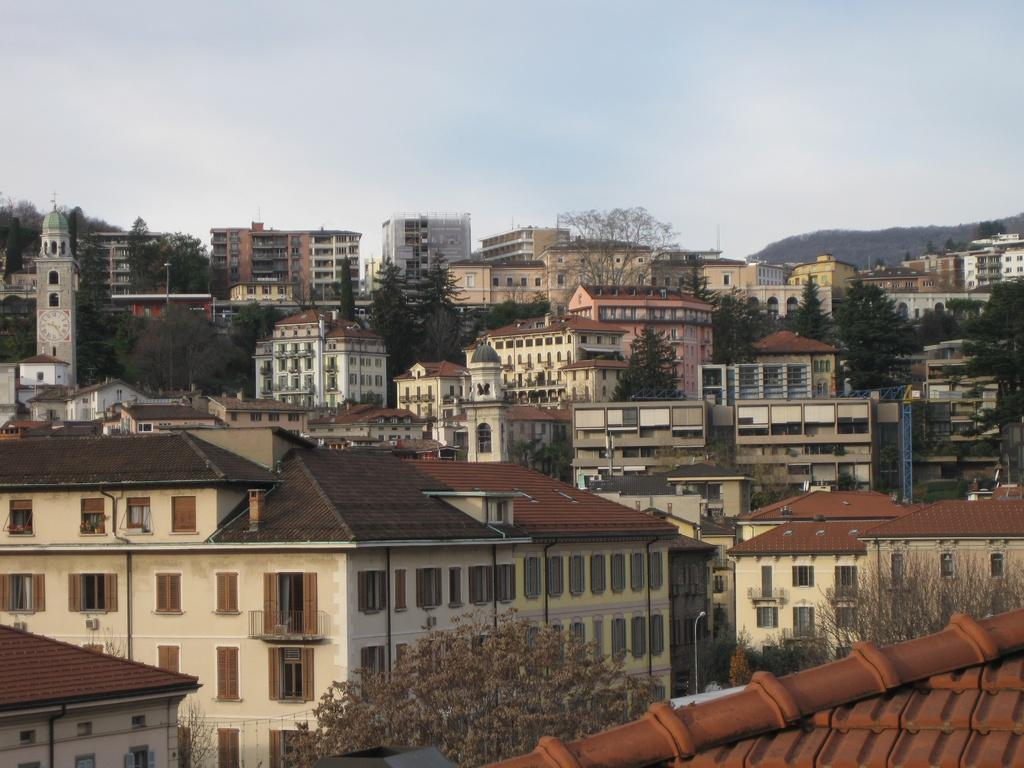What type of natural elements can be seen at the bottom of the image? There are trees at the bottom of the image. What type of man-made structures can be seen at the bottom of the image? There are houses and buildings at the bottom of the image. What is visible at the top of the image? The sky is visible at the top of the image. Can you tell me how many scissors are depicted in the image? There are no scissors present in the image. What type of structure is shown interacting with the trees at the bottom of the image? There is no structure shown interacting with the trees at the bottom of the image; only the trees, houses, and buildings are present. 